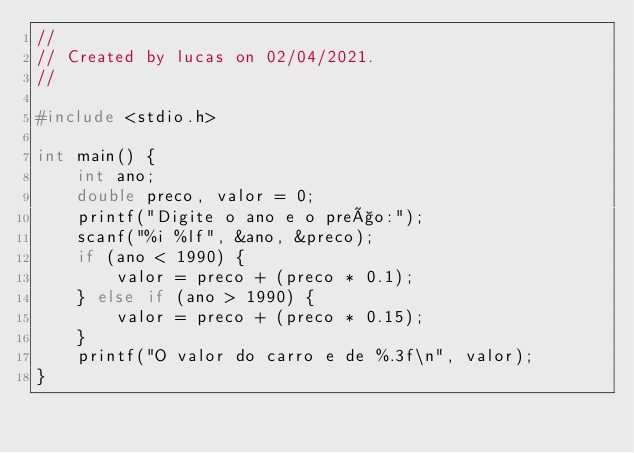Convert code to text. <code><loc_0><loc_0><loc_500><loc_500><_C_>//
// Created by lucas on 02/04/2021.
//

#include <stdio.h>

int main() {
    int ano;
    double preco, valor = 0;
    printf("Digite o ano e o preço:");
    scanf("%i %lf", &ano, &preco);
    if (ano < 1990) {
        valor = preco + (preco * 0.1);
    } else if (ano > 1990) {
        valor = preco + (preco * 0.15);
    }
    printf("O valor do carro e de %.3f\n", valor);
}</code> 